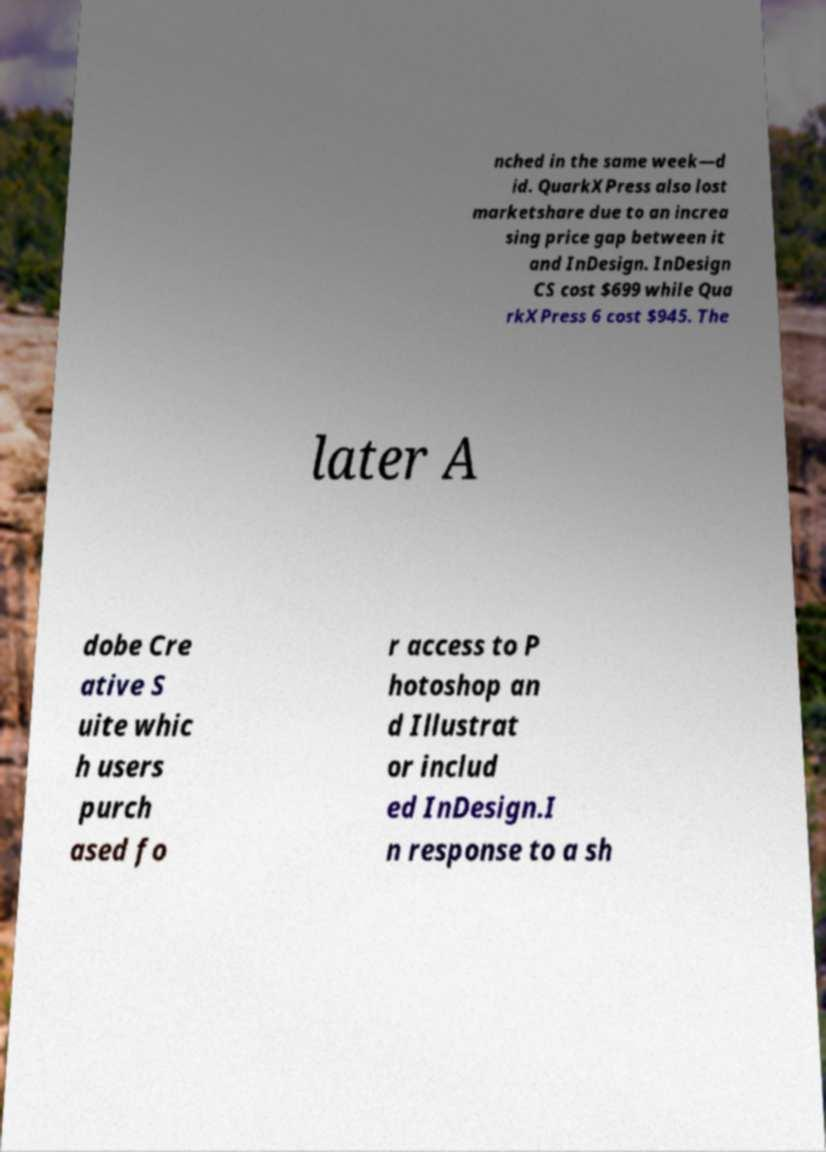Can you read and provide the text displayed in the image?This photo seems to have some interesting text. Can you extract and type it out for me? nched in the same week—d id. QuarkXPress also lost marketshare due to an increa sing price gap between it and InDesign. InDesign CS cost $699 while Qua rkXPress 6 cost $945. The later A dobe Cre ative S uite whic h users purch ased fo r access to P hotoshop an d Illustrat or includ ed InDesign.I n response to a sh 